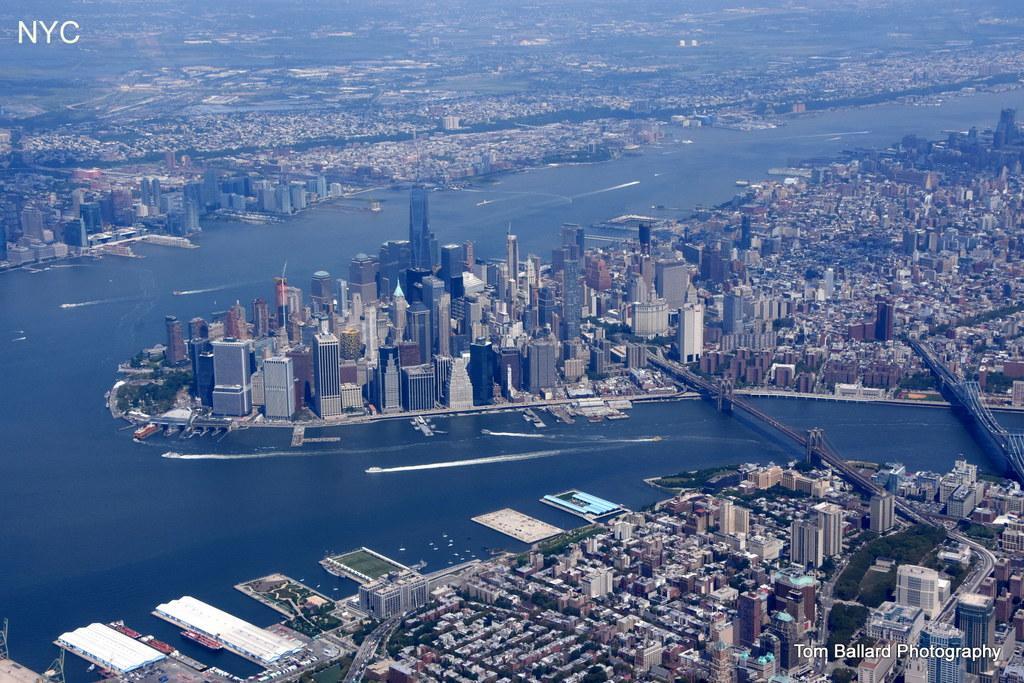Could you give a brief overview of what you see in this image? In this image we can see water. On the water there are boats. Also there are many buildings. In the top left corner and bottom right corner something is written. Also there are bridges. 